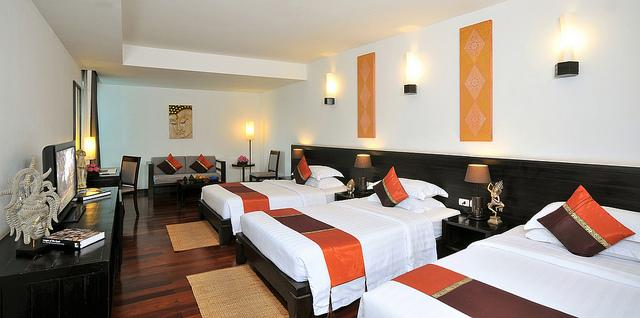In what continent is this hotel likely to be located? asia 